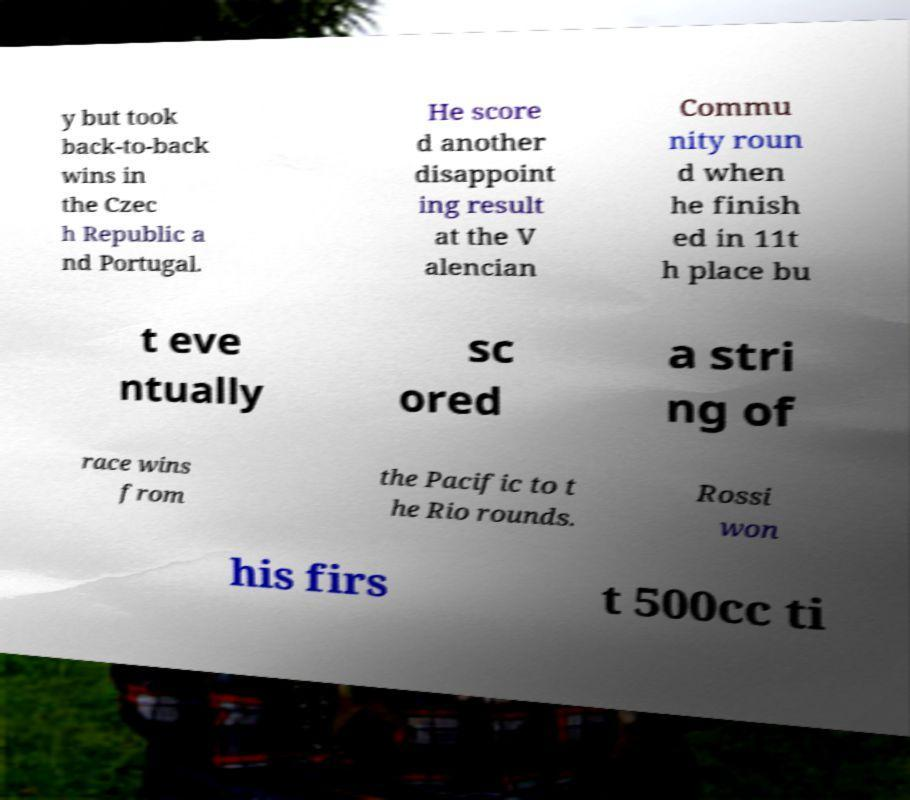For documentation purposes, I need the text within this image transcribed. Could you provide that? y but took back-to-back wins in the Czec h Republic a nd Portugal. He score d another disappoint ing result at the V alencian Commu nity roun d when he finish ed in 11t h place bu t eve ntually sc ored a stri ng of race wins from the Pacific to t he Rio rounds. Rossi won his firs t 500cc ti 